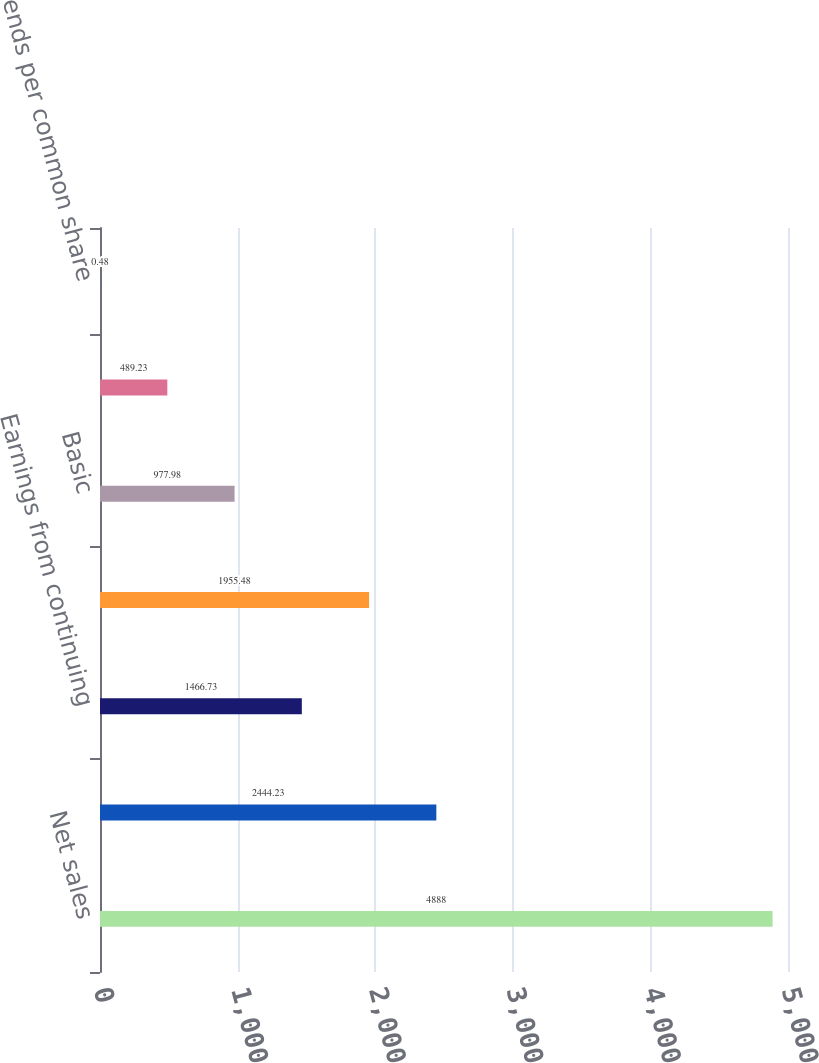<chart> <loc_0><loc_0><loc_500><loc_500><bar_chart><fcel>Net sales<fcel>Gross profit<fcel>Earnings from continuing<fcel>Net earnings common<fcel>Basic<fcel>Diluted<fcel>Dividends per common share<nl><fcel>4888<fcel>2444.23<fcel>1466.73<fcel>1955.48<fcel>977.98<fcel>489.23<fcel>0.48<nl></chart> 